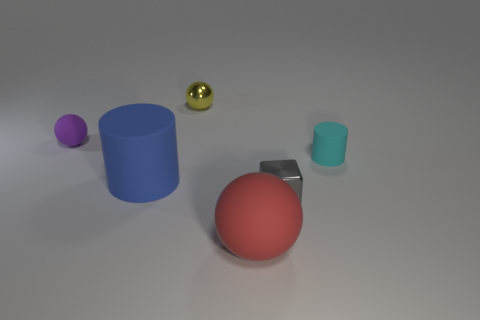Subtract all matte spheres. How many spheres are left? 1 Add 1 large blue shiny objects. How many objects exist? 7 Subtract 1 spheres. How many spheres are left? 2 Subtract all cylinders. How many objects are left? 4 Subtract all green spheres. Subtract all green cylinders. How many spheres are left? 3 Add 1 big matte cubes. How many big matte cubes exist? 1 Subtract 0 yellow cylinders. How many objects are left? 6 Subtract all big brown metal cylinders. Subtract all red balls. How many objects are left? 5 Add 5 yellow balls. How many yellow balls are left? 6 